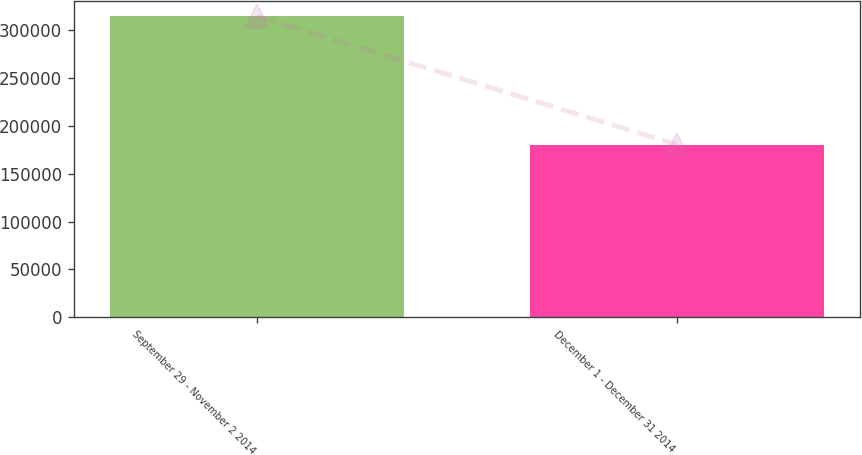Convert chart to OTSL. <chart><loc_0><loc_0><loc_500><loc_500><bar_chart><fcel>September 29 - November 2 2014<fcel>December 1 - December 31 2014<nl><fcel>314276<fcel>180214<nl></chart> 